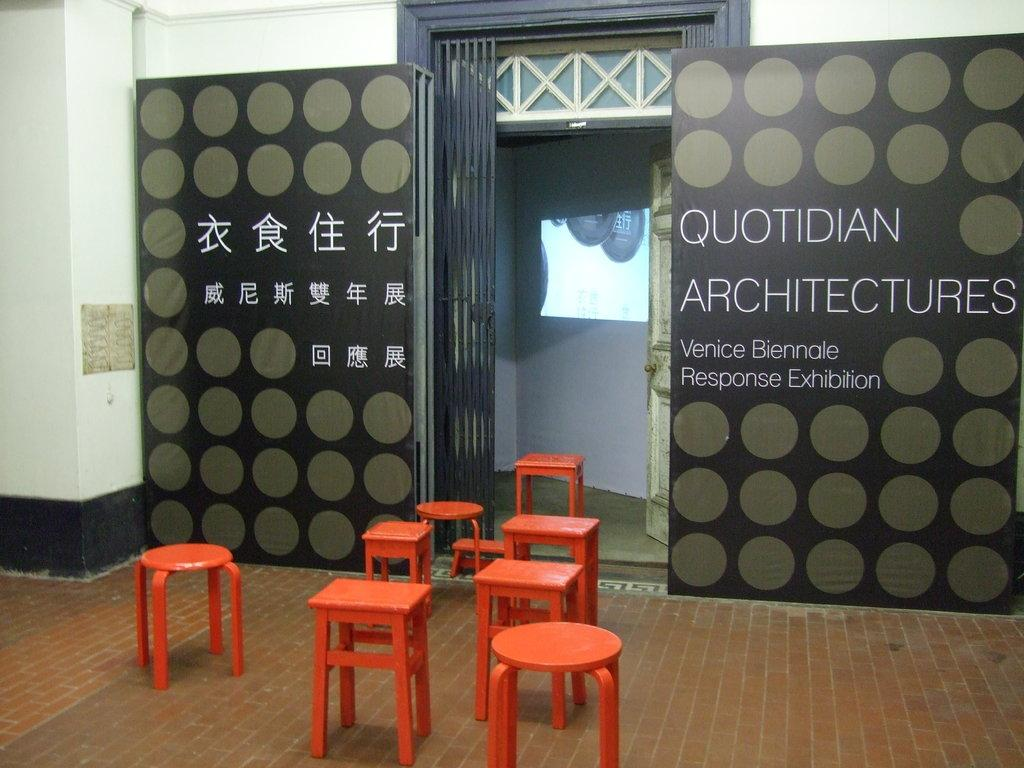What color are the chairs in the image? The chairs in the image are red. Where are the chairs located in the image? The chairs are on the floor. What can be seen in the center of the image? There is a gate in the center of the image. What is beside the gate in the image? There is a banner beside the gate. What is on the left side of the image? There is a pillar on the left side of the image. What is the taste of the moon in the image? There is no moon present in the image, so it is not possible to determine its taste. 